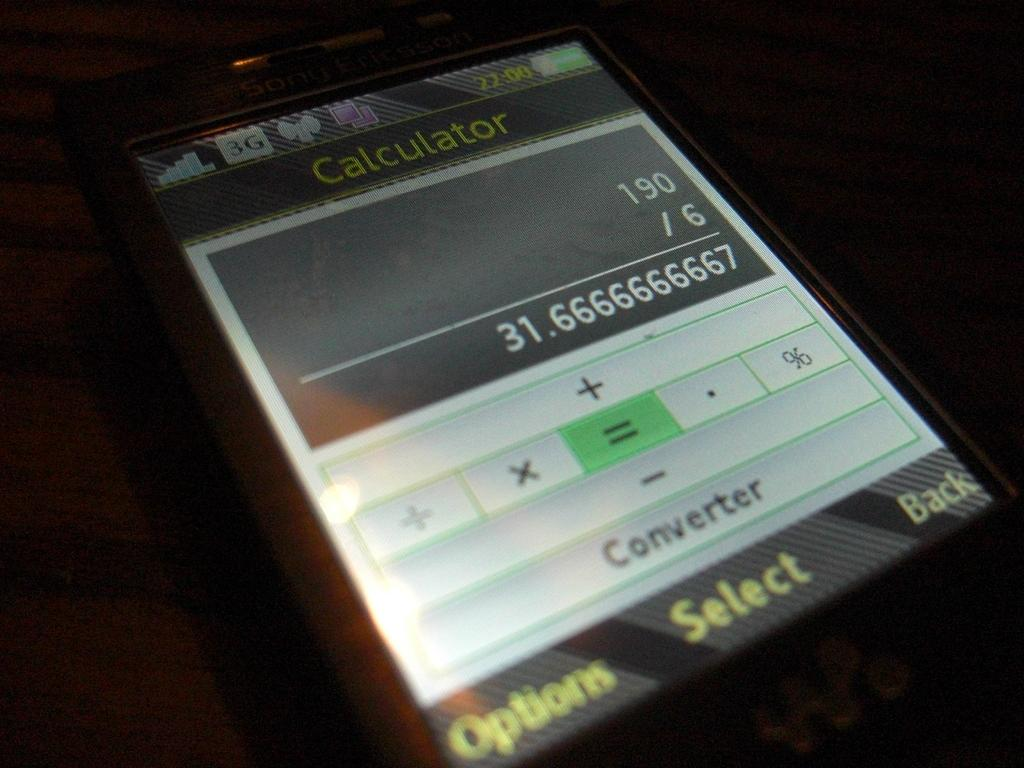Provide a one-sentence caption for the provided image. An electronic calculator is shown on a small screen with a division problem displayed. 